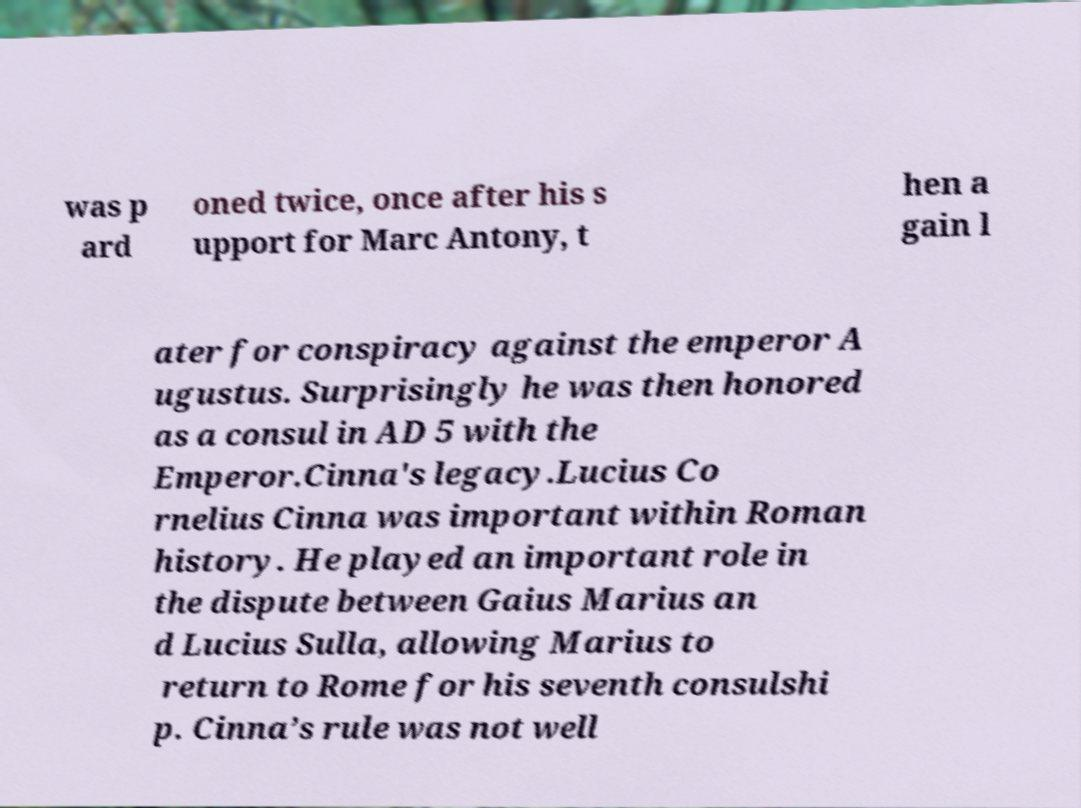Could you assist in decoding the text presented in this image and type it out clearly? was p ard oned twice, once after his s upport for Marc Antony, t hen a gain l ater for conspiracy against the emperor A ugustus. Surprisingly he was then honored as a consul in AD 5 with the Emperor.Cinna's legacy.Lucius Co rnelius Cinna was important within Roman history. He played an important role in the dispute between Gaius Marius an d Lucius Sulla, allowing Marius to return to Rome for his seventh consulshi p. Cinna’s rule was not well 